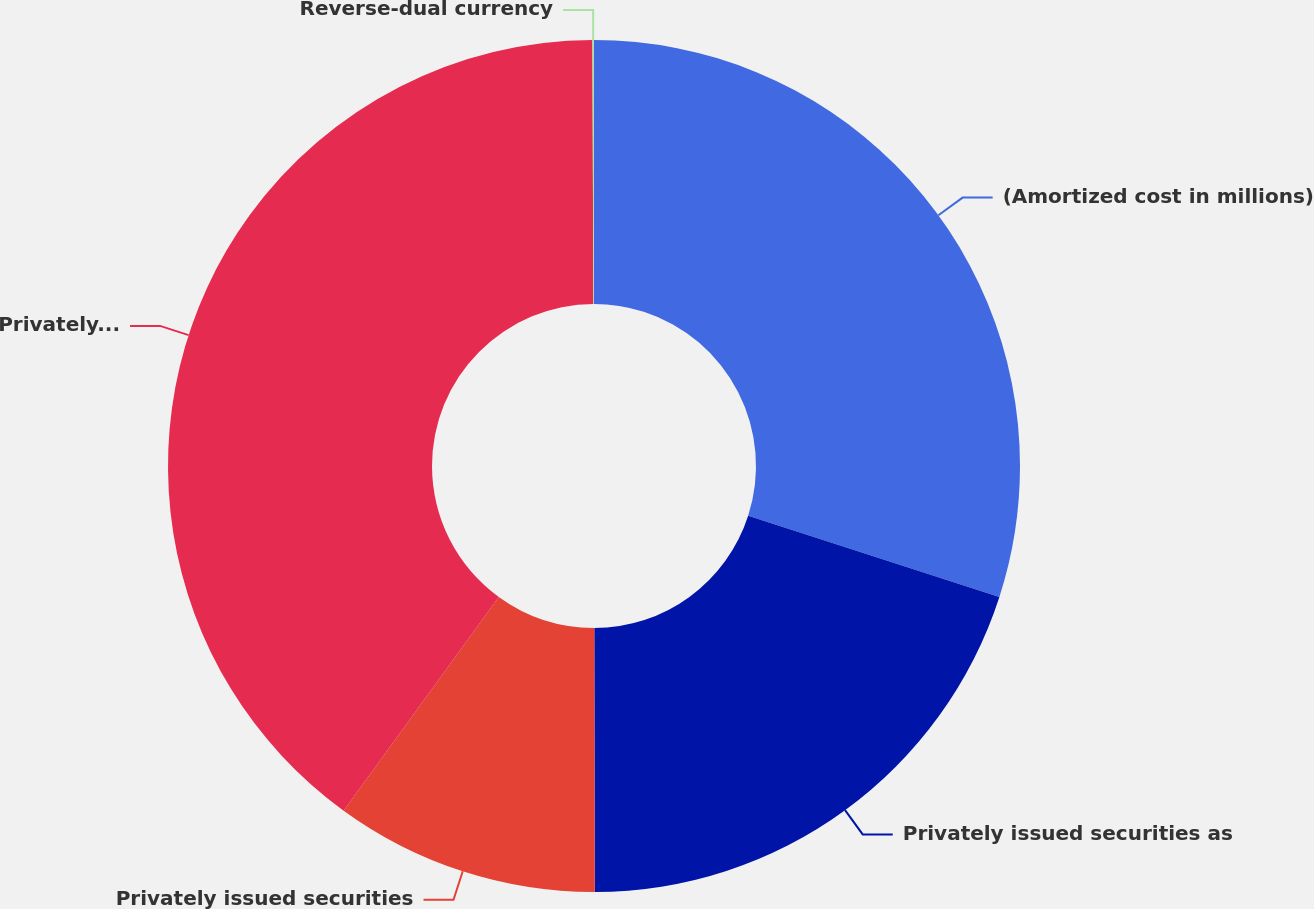<chart> <loc_0><loc_0><loc_500><loc_500><pie_chart><fcel>(Amortized cost in millions)<fcel>Privately issued securities as<fcel>Privately issued securities<fcel>Privately issued reverse-dual<fcel>Reverse-dual currency<nl><fcel>29.97%<fcel>20.0%<fcel>10.03%<fcel>39.94%<fcel>0.06%<nl></chart> 